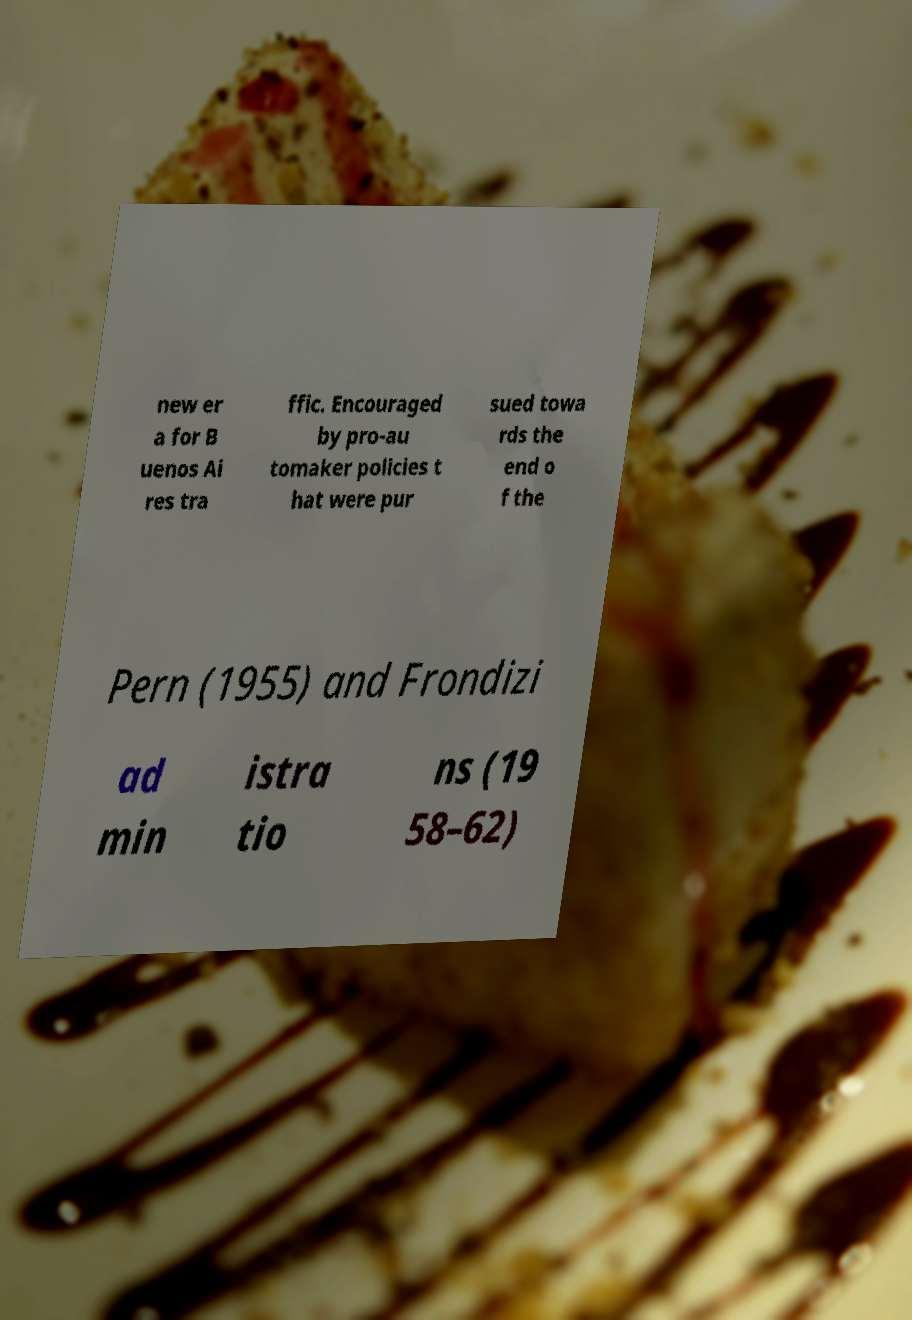Could you extract and type out the text from this image? new er a for B uenos Ai res tra ffic. Encouraged by pro-au tomaker policies t hat were pur sued towa rds the end o f the Pern (1955) and Frondizi ad min istra tio ns (19 58–62) 